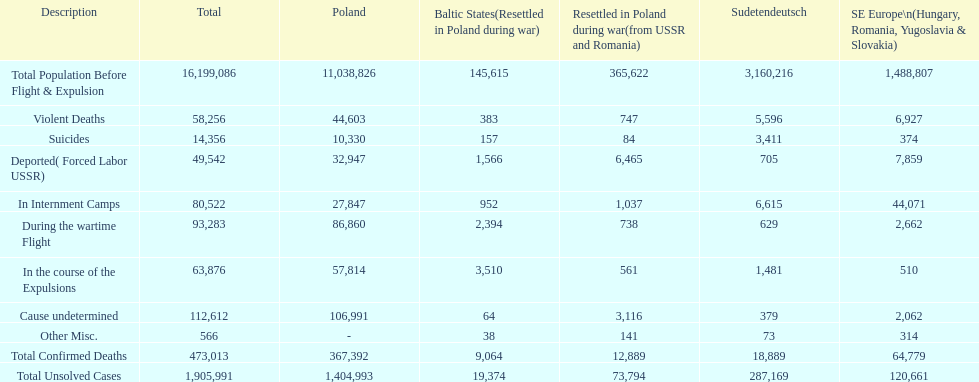What is the total number of violent deaths across all regions? 58,256. 